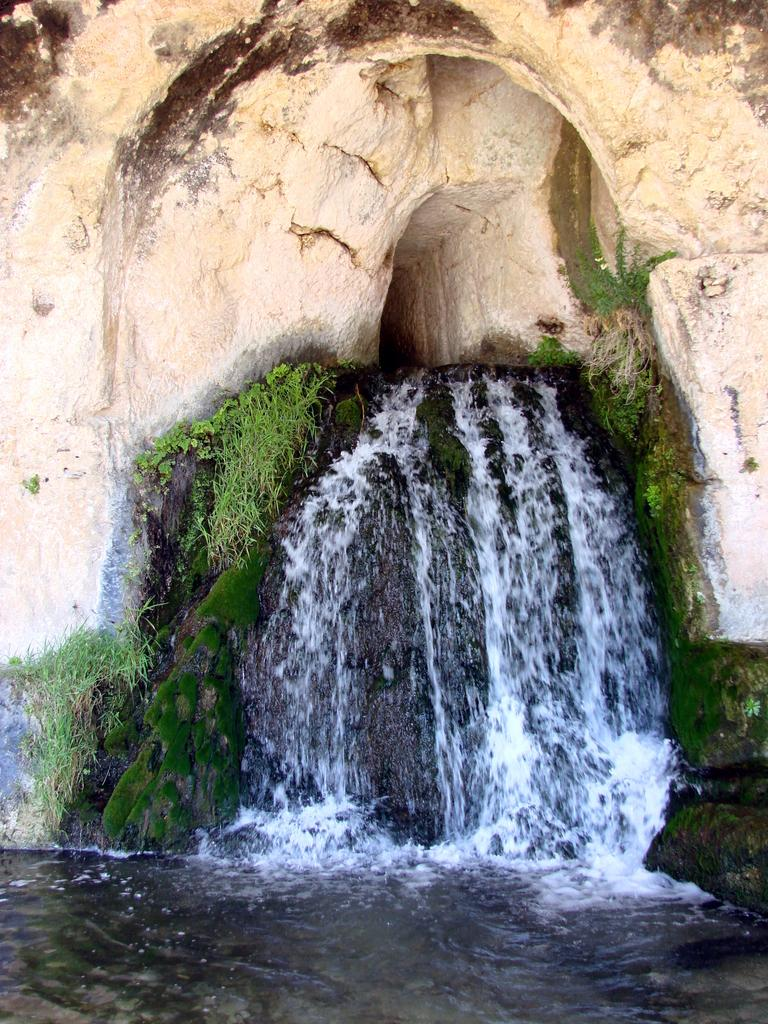What is the main subject of the image? There is a rock in the image. What can be seen from the rock in the image? There is a waterfall visible from the rock. What type of vegetation is near the waterfall? There are plants near the waterfall. How many goldfish are swimming in the waterfall in the image? There are no goldfish present in the image; it features a rock, a waterfall, and plants. What type of prose can be heard being recited near the waterfall in the image? There is no indication of any prose or recitation in the image; it only shows a rock, a waterfall, and plants. 